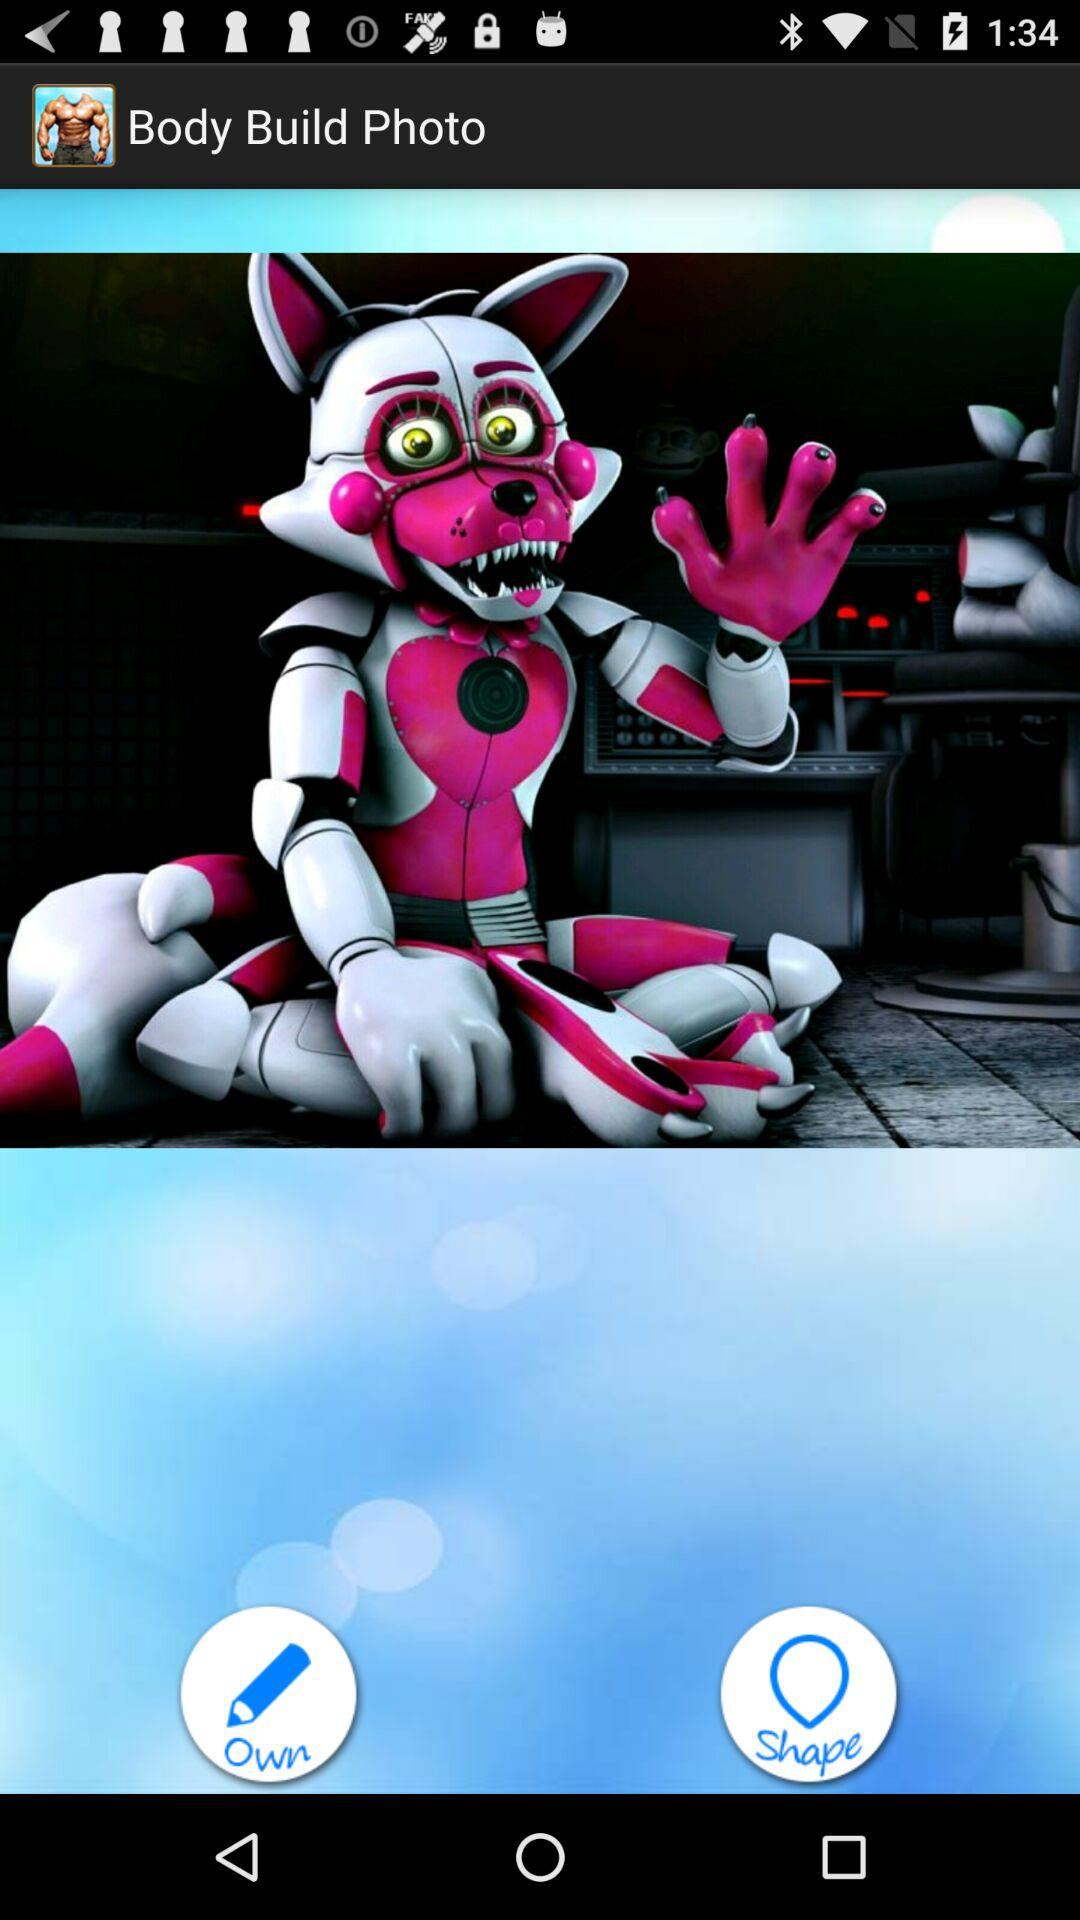What is the application name? The application name is "Body Build Photo". 